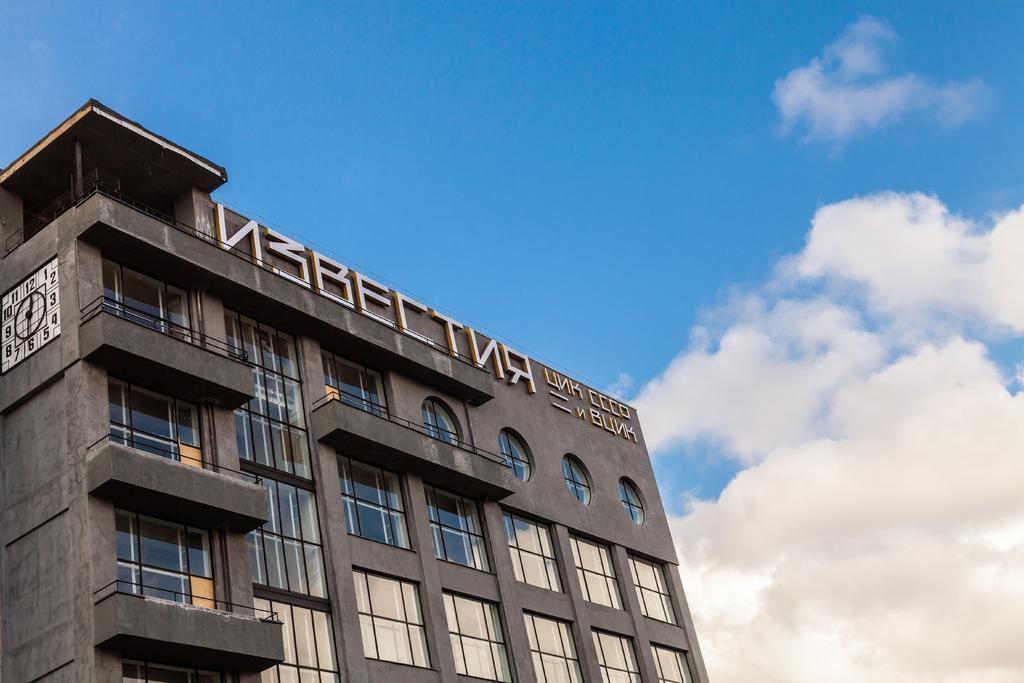Describe this image in one or two sentences. In this picture I can see a building with windows and a clock, and in the background there is the sky. 